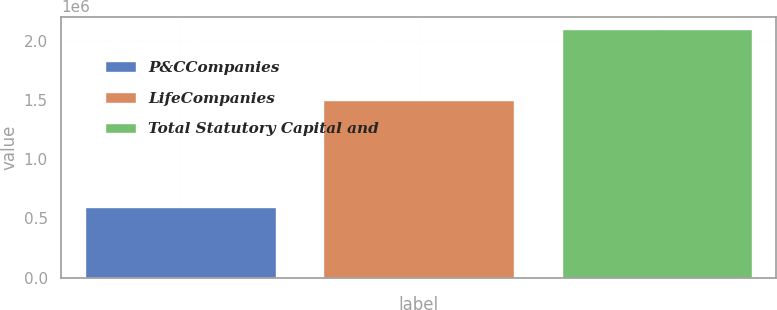Convert chart to OTSL. <chart><loc_0><loc_0><loc_500><loc_500><bar_chart><fcel>P&CCompanies<fcel>LifeCompanies<fcel>Total Statutory Capital and<nl><fcel>598190<fcel>1.50226e+06<fcel>2.10045e+06<nl></chart> 